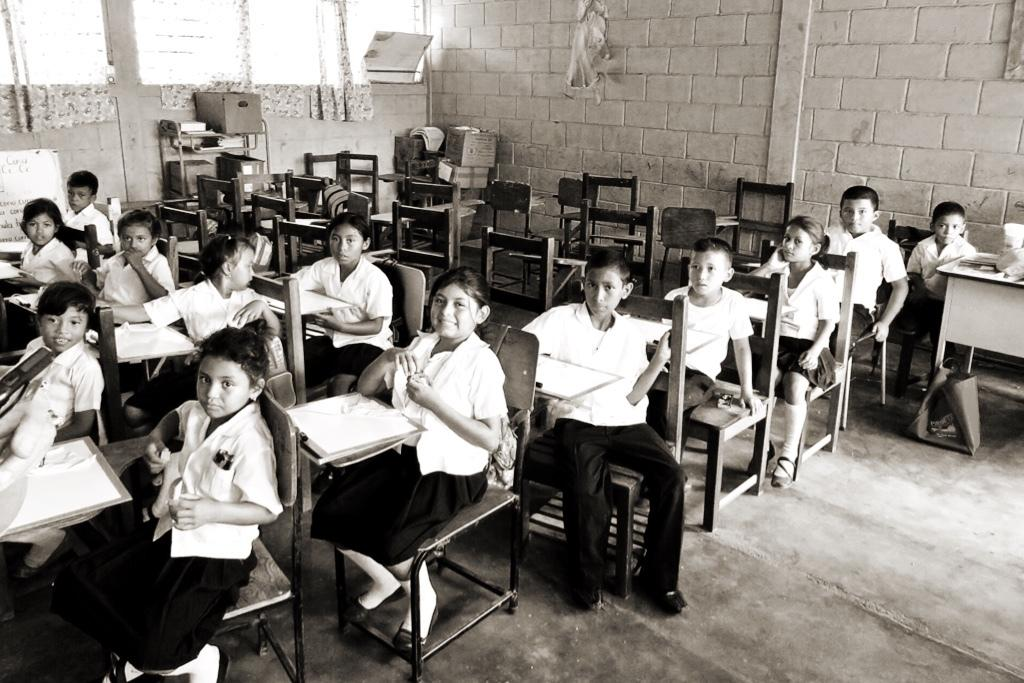Who is present in the image? There are children in the image. What are the children doing in the image? The children are sitting on chairs. Where does the image seem to take place? The setting appears to be a classroom. What are the children wearing in the image? The children are wearing uniforms. What type of suit is the child wearing in the image? There is no suit present in the image; the children are wearing uniforms. 